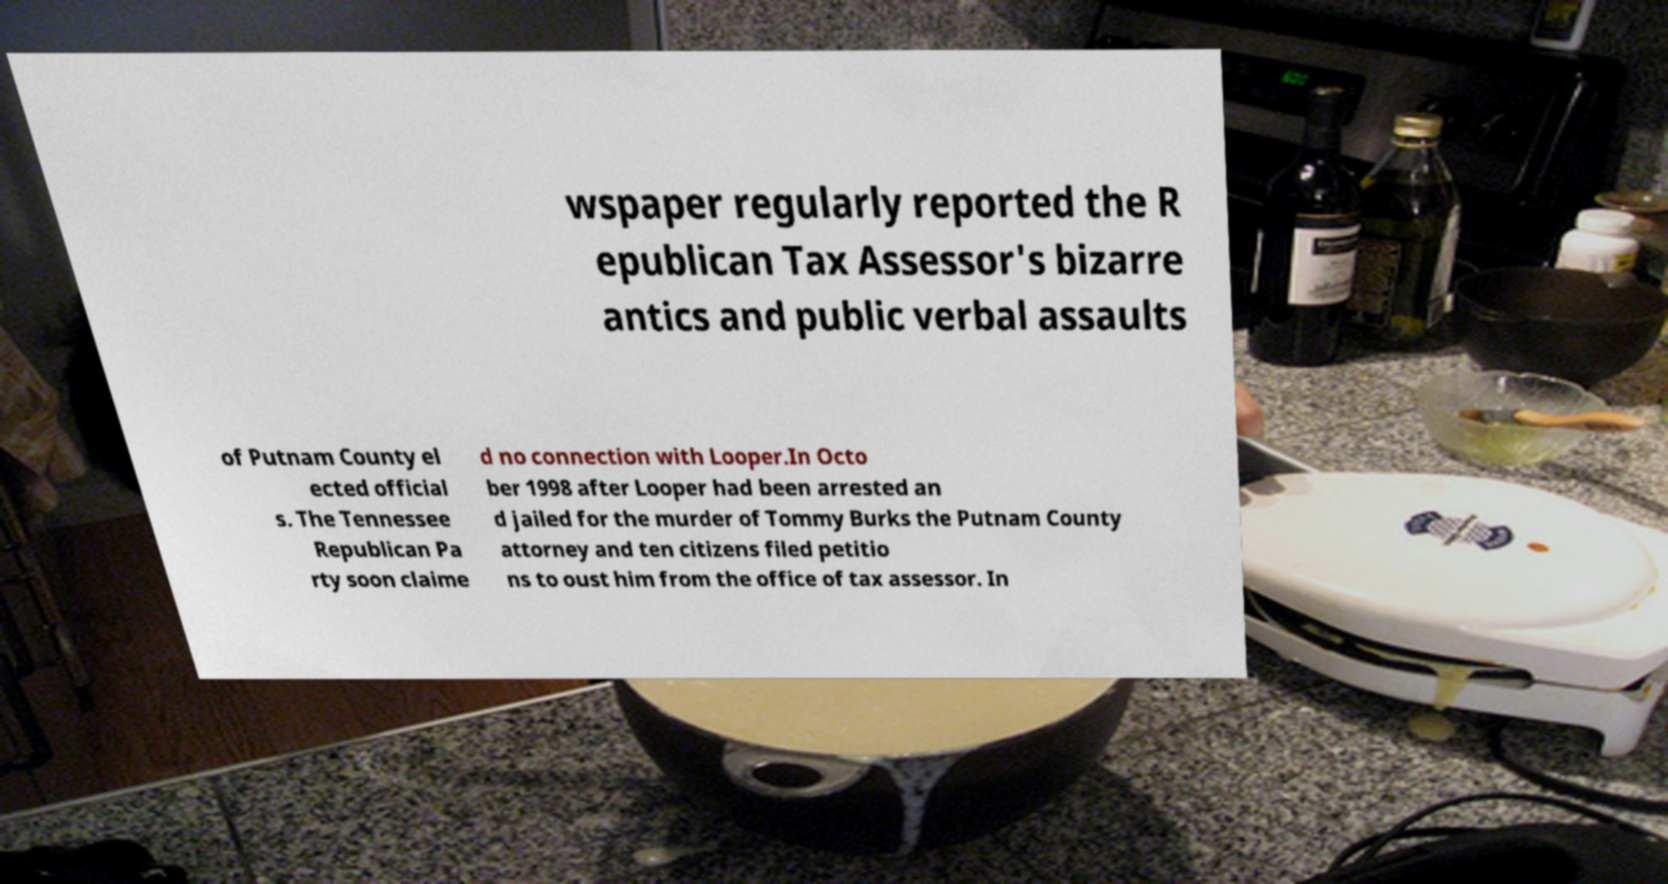Could you assist in decoding the text presented in this image and type it out clearly? wspaper regularly reported the R epublican Tax Assessor's bizarre antics and public verbal assaults of Putnam County el ected official s. The Tennessee Republican Pa rty soon claime d no connection with Looper.In Octo ber 1998 after Looper had been arrested an d jailed for the murder of Tommy Burks the Putnam County attorney and ten citizens filed petitio ns to oust him from the office of tax assessor. In 